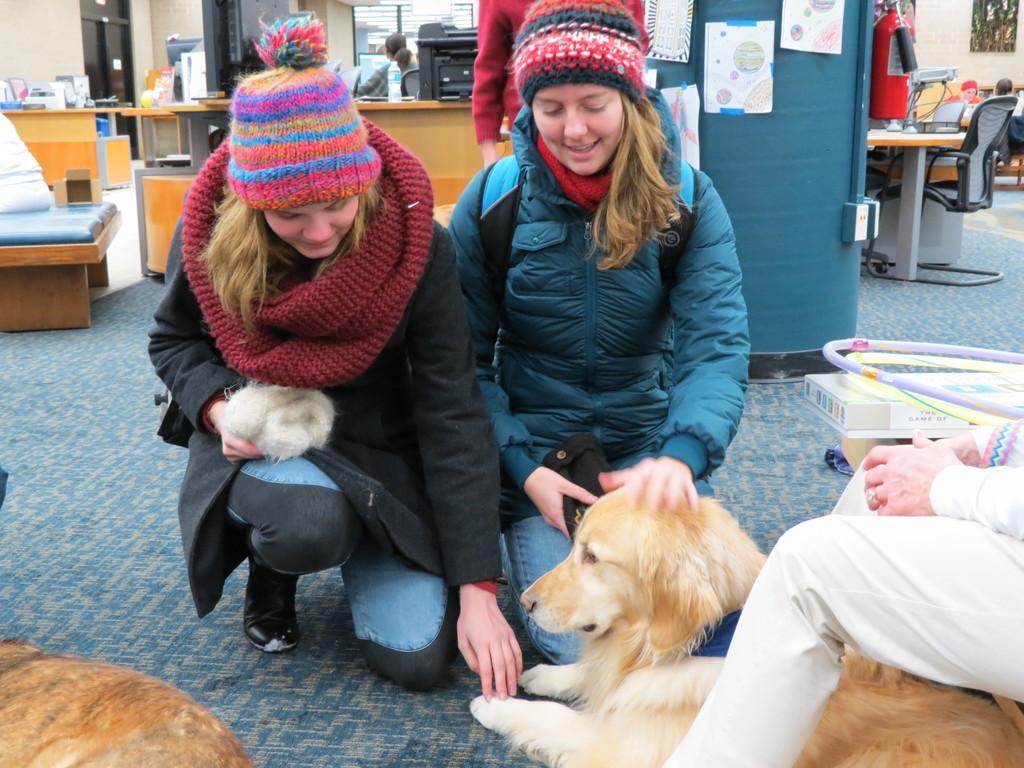Could you give a brief overview of what you see in this image? There are two ladies sitting on the floor. They both are wearing caps and jackets. They are holding the dog's head and leg. There is another person sitting to the right corner. In the background there is a table. On the table there is a printer and to the left corner there is a chair. And to the right corner there is table , chair and fire extinguisher. 